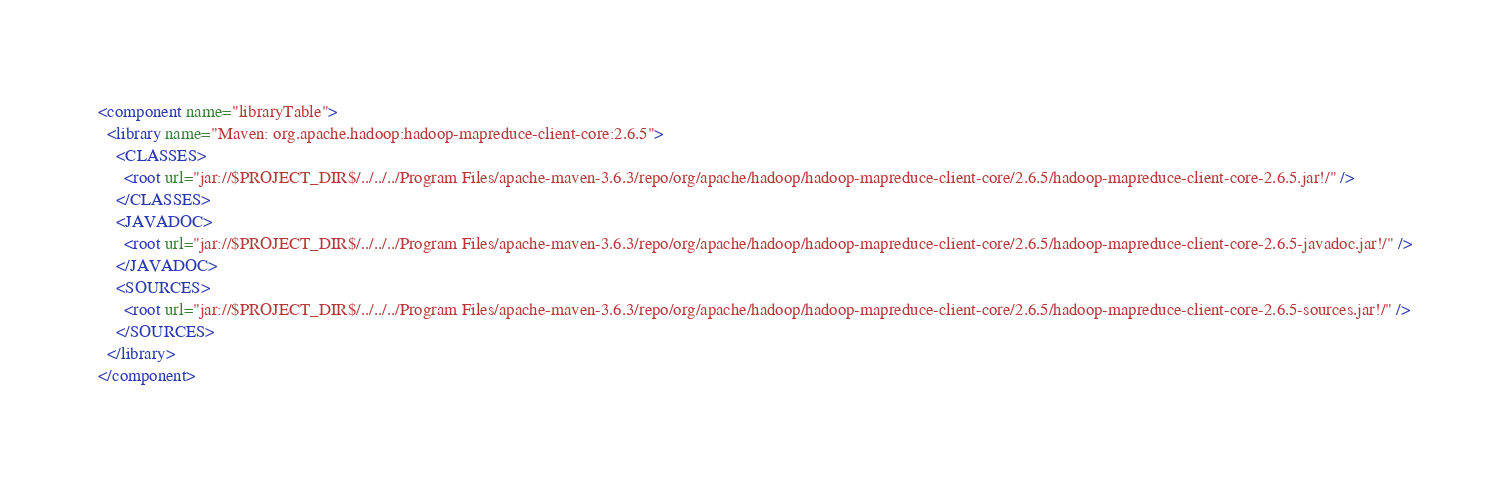Convert code to text. <code><loc_0><loc_0><loc_500><loc_500><_XML_><component name="libraryTable">
  <library name="Maven: org.apache.hadoop:hadoop-mapreduce-client-core:2.6.5">
    <CLASSES>
      <root url="jar://$PROJECT_DIR$/../../../Program Files/apache-maven-3.6.3/repo/org/apache/hadoop/hadoop-mapreduce-client-core/2.6.5/hadoop-mapreduce-client-core-2.6.5.jar!/" />
    </CLASSES>
    <JAVADOC>
      <root url="jar://$PROJECT_DIR$/../../../Program Files/apache-maven-3.6.3/repo/org/apache/hadoop/hadoop-mapreduce-client-core/2.6.5/hadoop-mapreduce-client-core-2.6.5-javadoc.jar!/" />
    </JAVADOC>
    <SOURCES>
      <root url="jar://$PROJECT_DIR$/../../../Program Files/apache-maven-3.6.3/repo/org/apache/hadoop/hadoop-mapreduce-client-core/2.6.5/hadoop-mapreduce-client-core-2.6.5-sources.jar!/" />
    </SOURCES>
  </library>
</component></code> 